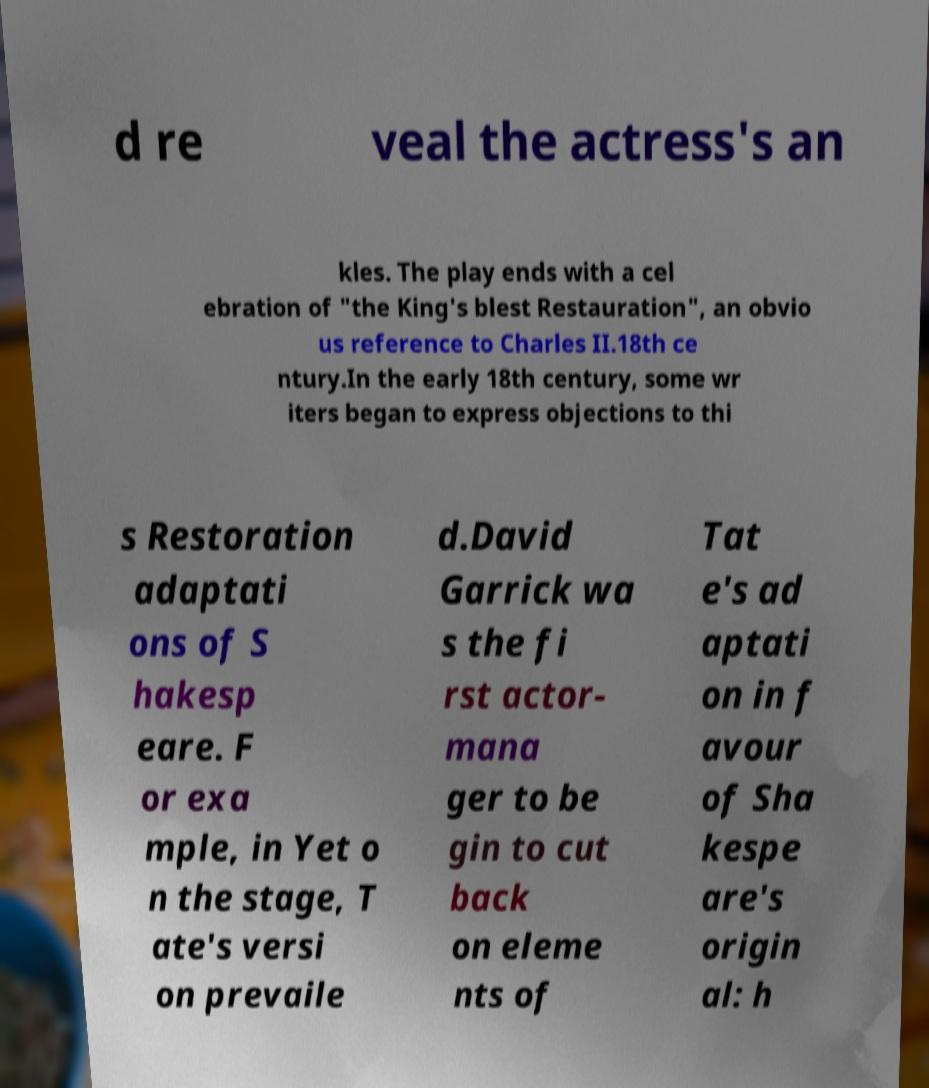Could you assist in decoding the text presented in this image and type it out clearly? d re veal the actress's an kles. The play ends with a cel ebration of "the King's blest Restauration", an obvio us reference to Charles II.18th ce ntury.In the early 18th century, some wr iters began to express objections to thi s Restoration adaptati ons of S hakesp eare. F or exa mple, in Yet o n the stage, T ate's versi on prevaile d.David Garrick wa s the fi rst actor- mana ger to be gin to cut back on eleme nts of Tat e's ad aptati on in f avour of Sha kespe are's origin al: h 